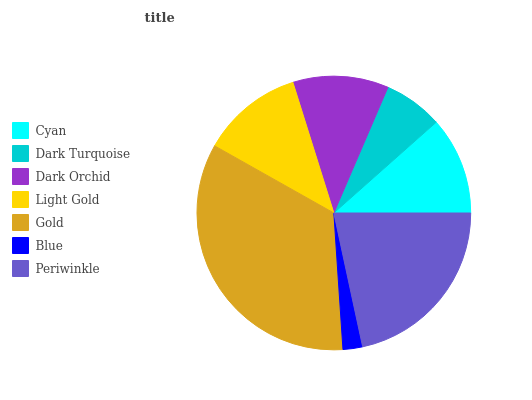Is Blue the minimum?
Answer yes or no. Yes. Is Gold the maximum?
Answer yes or no. Yes. Is Dark Turquoise the minimum?
Answer yes or no. No. Is Dark Turquoise the maximum?
Answer yes or no. No. Is Cyan greater than Dark Turquoise?
Answer yes or no. Yes. Is Dark Turquoise less than Cyan?
Answer yes or no. Yes. Is Dark Turquoise greater than Cyan?
Answer yes or no. No. Is Cyan less than Dark Turquoise?
Answer yes or no. No. Is Cyan the high median?
Answer yes or no. Yes. Is Cyan the low median?
Answer yes or no. Yes. Is Dark Orchid the high median?
Answer yes or no. No. Is Light Gold the low median?
Answer yes or no. No. 